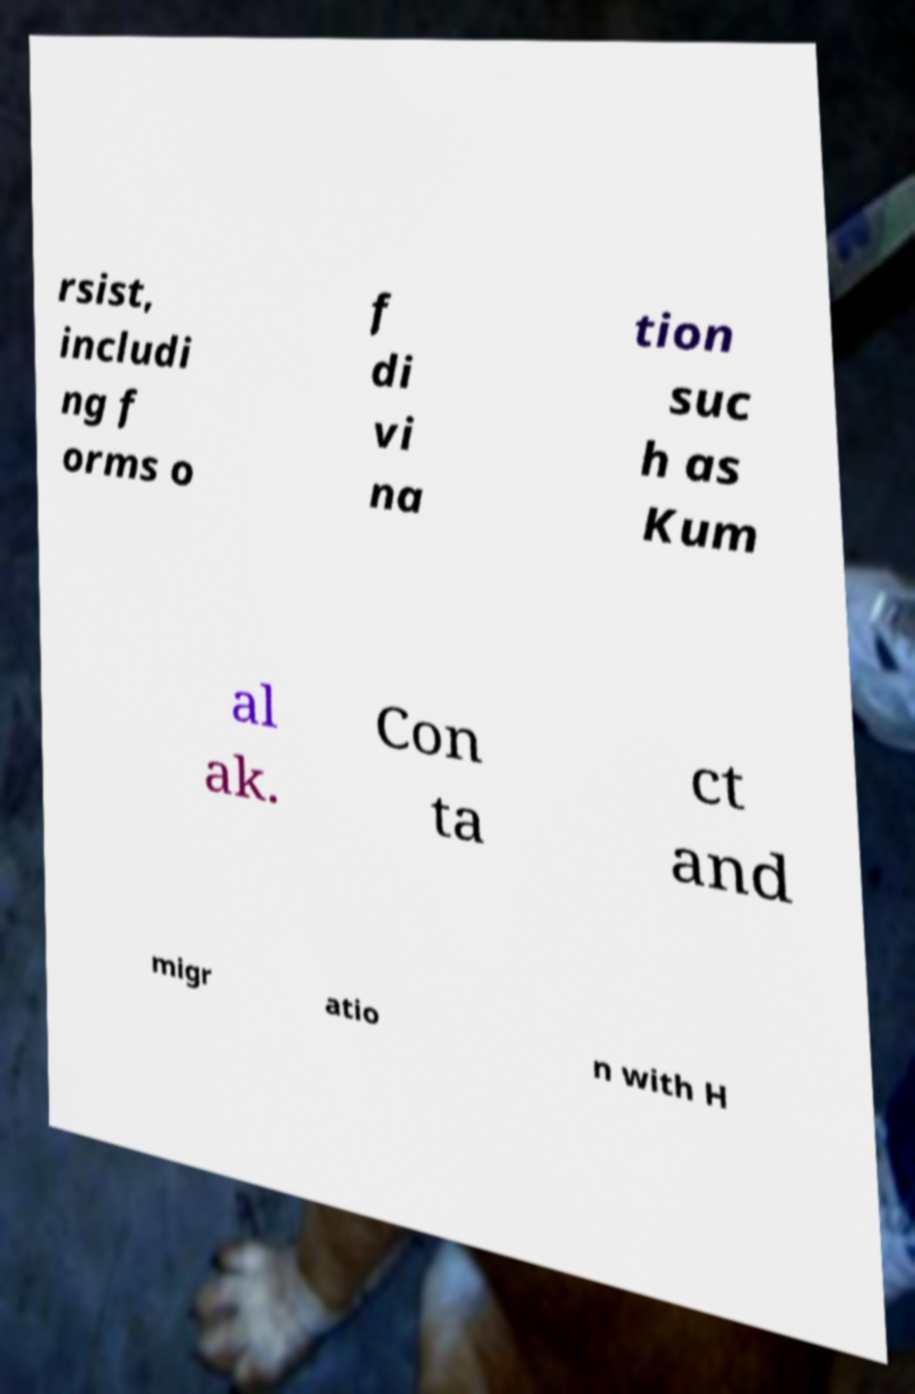Please identify and transcribe the text found in this image. rsist, includi ng f orms o f di vi na tion suc h as Kum al ak. Con ta ct and migr atio n with H 